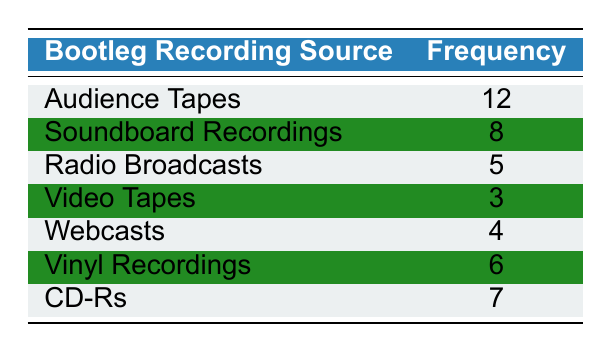What's the most frequent bootleg recording source? The table lists the frequencies for different bootleg recording sources. The highest frequency is for Audience Tapes, which has a frequency of 12.
Answer: Audience Tapes How many sources have a frequency of 5 or higher? By examining the frequencies in the table, we see that the following sources have a frequency of 5 or higher: Audience Tapes (12), Soundboard Recordings (8), CD-Rs (7), Vinyl Recordings (6), and Radio Broadcasts (5). This totals 5 sources.
Answer: 5 What is the combined frequency of Video Tapes and Webcasts? The frequency of Video Tapes is 3, and the frequency of Webcasts is 4. Adding these two gives 3 + 4 = 7.
Answer: 7 Is Soundboard Recordings more frequent than Radio Broadcasts? The frequency for Soundboard Recordings is 8 and for Radio Broadcasts is 5. Since 8 is greater than 5, the statement is true.
Answer: Yes What's the difference in frequency between the most and least used sources? The most used source is Audience Tapes with a frequency of 12, while the least used source is Video Tapes with a frequency of 3. The difference is calculated as 12 - 3 = 9.
Answer: 9 What is the average frequency of all bootleg recording sources? To find the average, we first sum the frequencies: 12 + 8 + 5 + 3 + 4 + 6 + 7 = 45. Next, we count the sources, which total 7. The average is 45 / 7 = approximately 6.43.
Answer: 6.43 Which bootleg source has the second highest frequency? By looking at the frequencies, Audience Tapes has the highest frequency of 12, and Soundboard Recordings has the next highest at 8, making it the second highest.
Answer: Soundboard Recordings How many more Audience Tapes are there than Webcasts? The frequency for Audience Tapes is 12 and for Webcasts, it is 4. The difference is 12 - 4 = 8, indicating there are 8 more Audience Tapes.
Answer: 8 